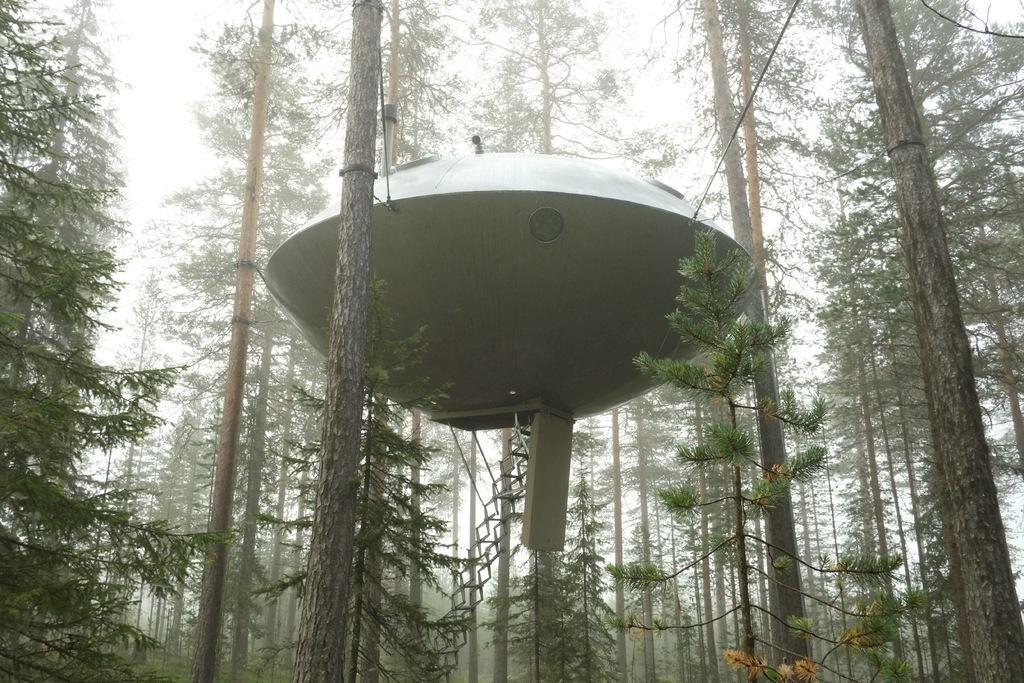Please provide a concise description of this image. It is an object in the shape of an oval, it has stairs and there are trees in this image. 